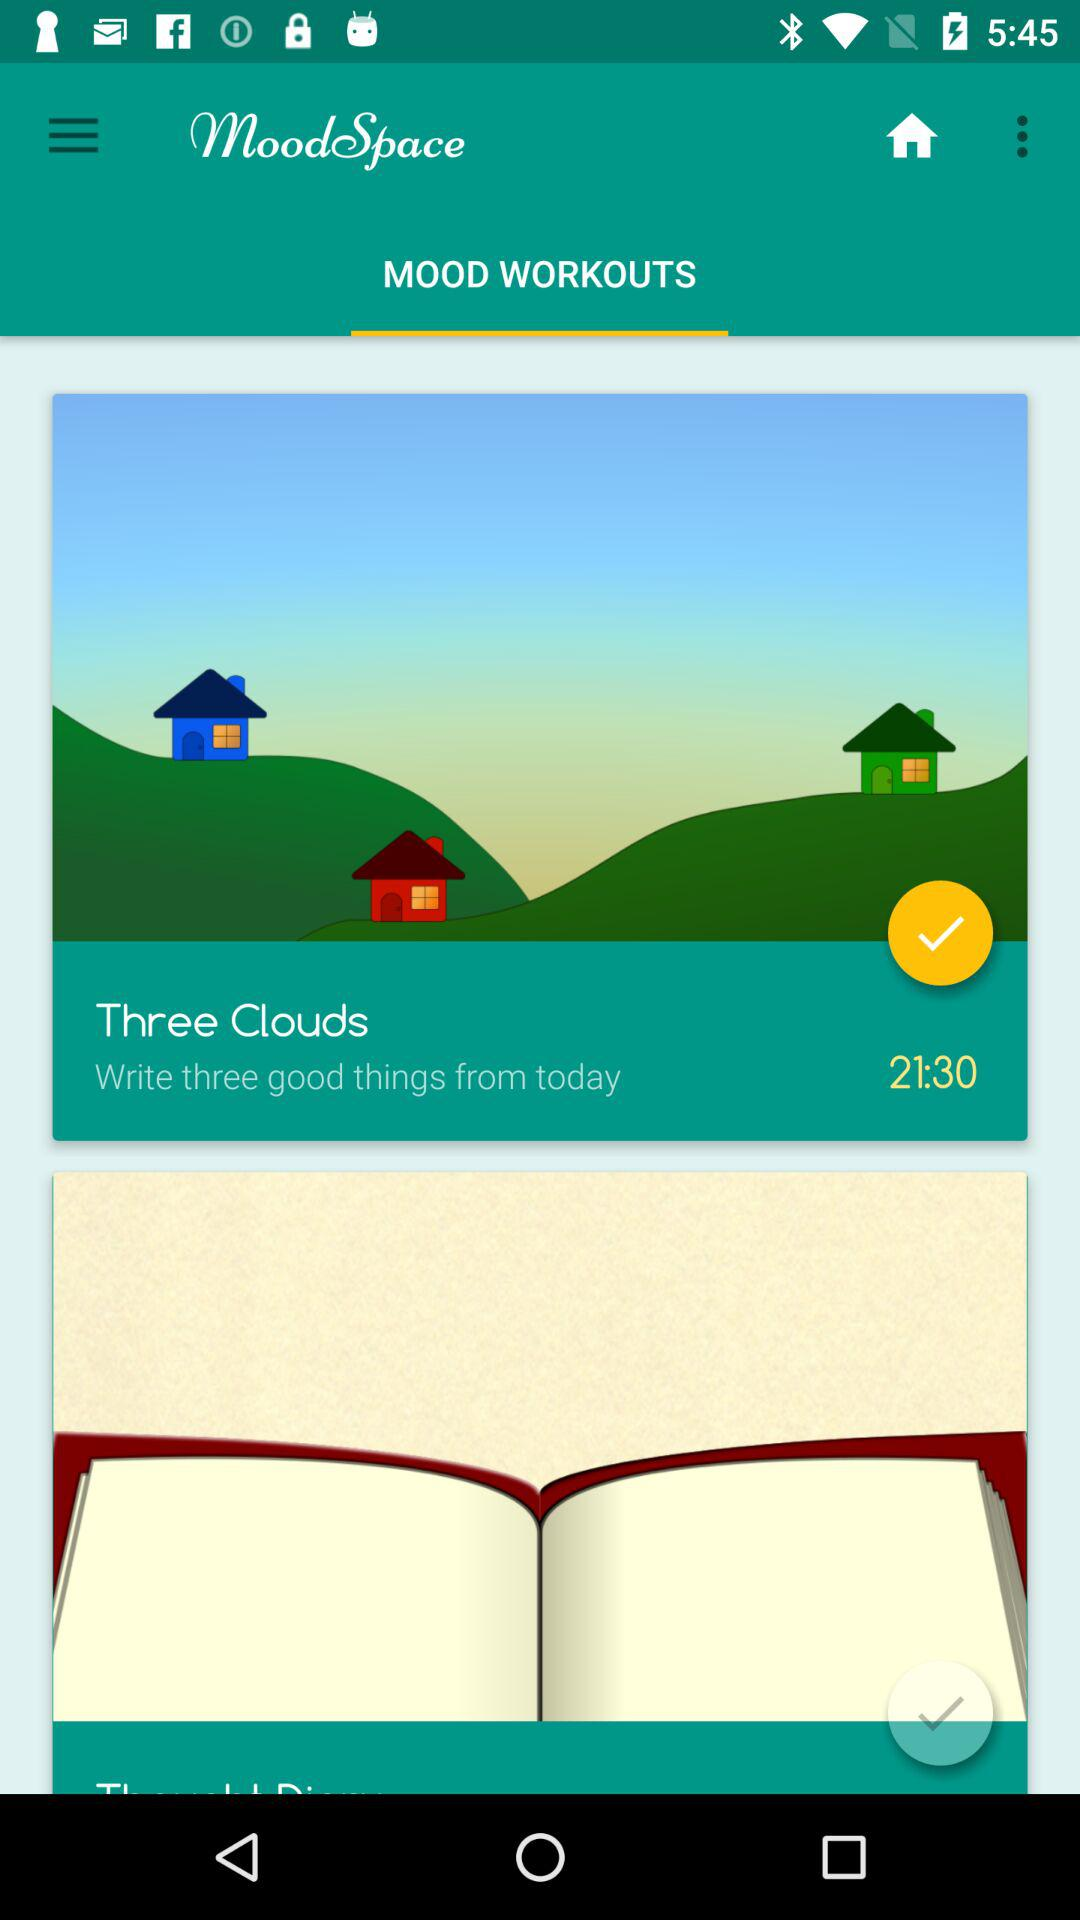Which tab is selected? The selected tab is "MOOD WORKOUTS". 